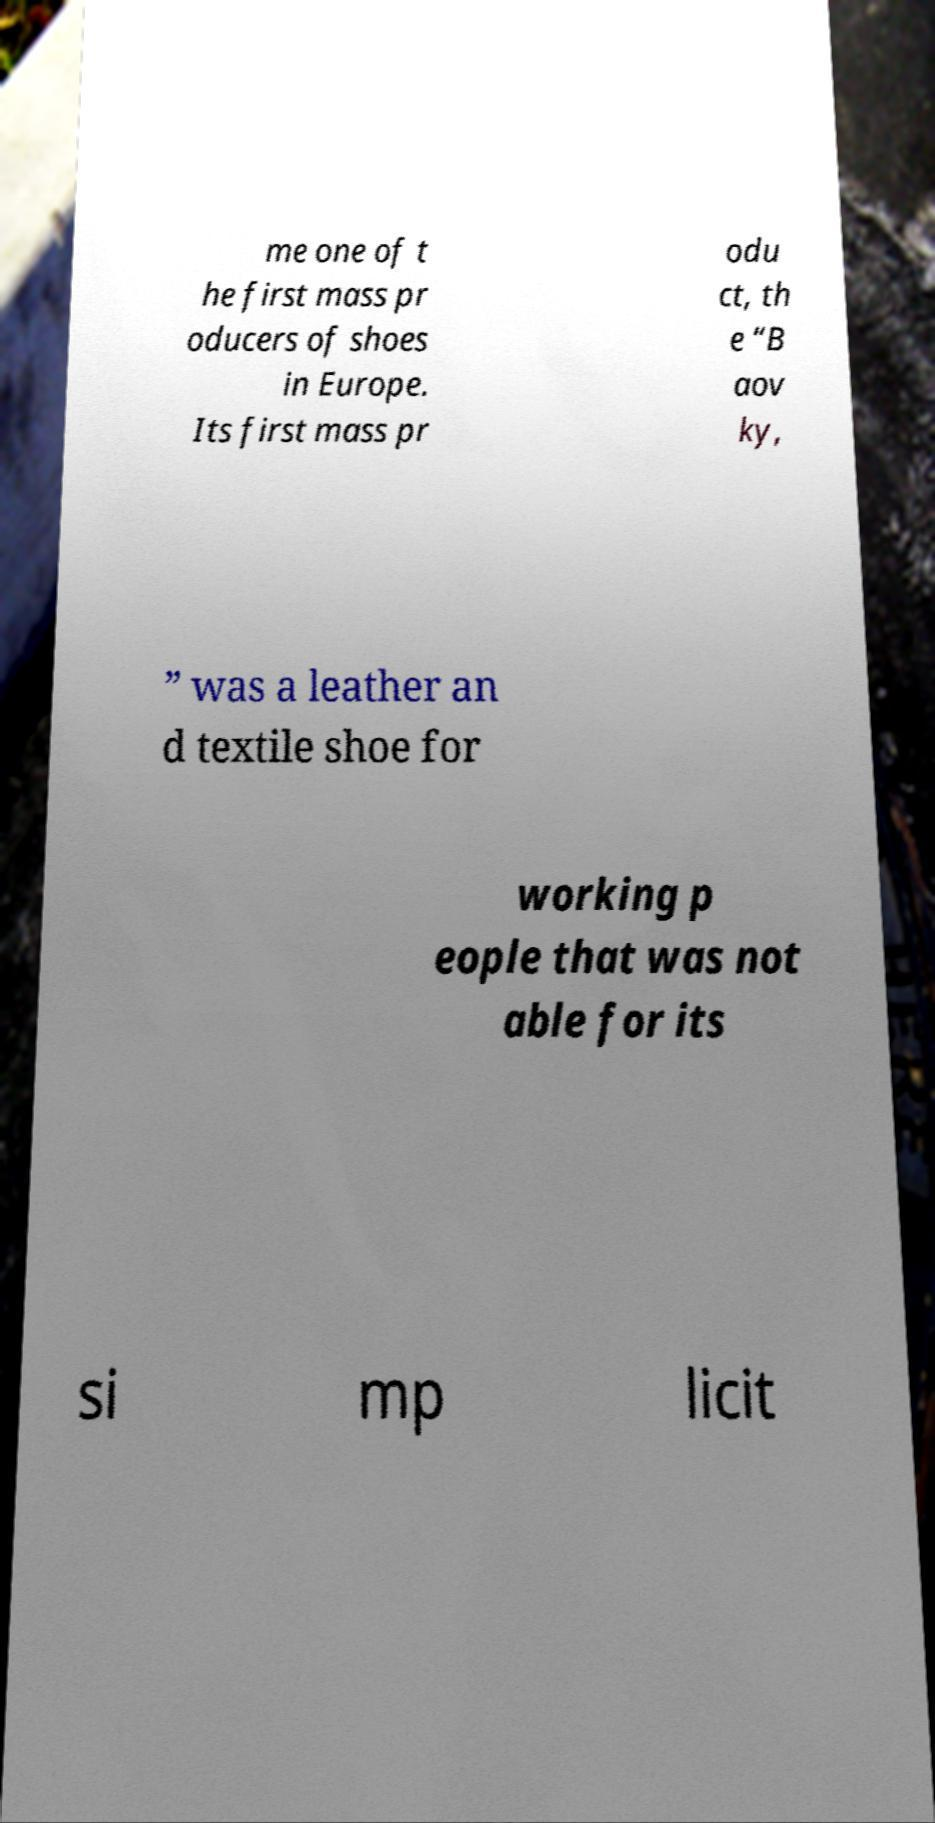Could you assist in decoding the text presented in this image and type it out clearly? me one of t he first mass pr oducers of shoes in Europe. Its first mass pr odu ct, th e “B aov ky, ” was a leather an d textile shoe for working p eople that was not able for its si mp licit 